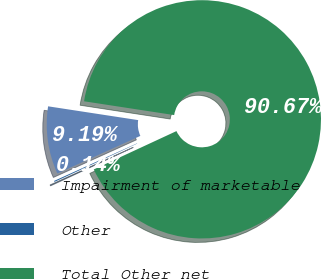Convert chart to OTSL. <chart><loc_0><loc_0><loc_500><loc_500><pie_chart><fcel>Impairment of marketable<fcel>Other<fcel>Total Other net<nl><fcel>9.19%<fcel>0.14%<fcel>90.67%<nl></chart> 